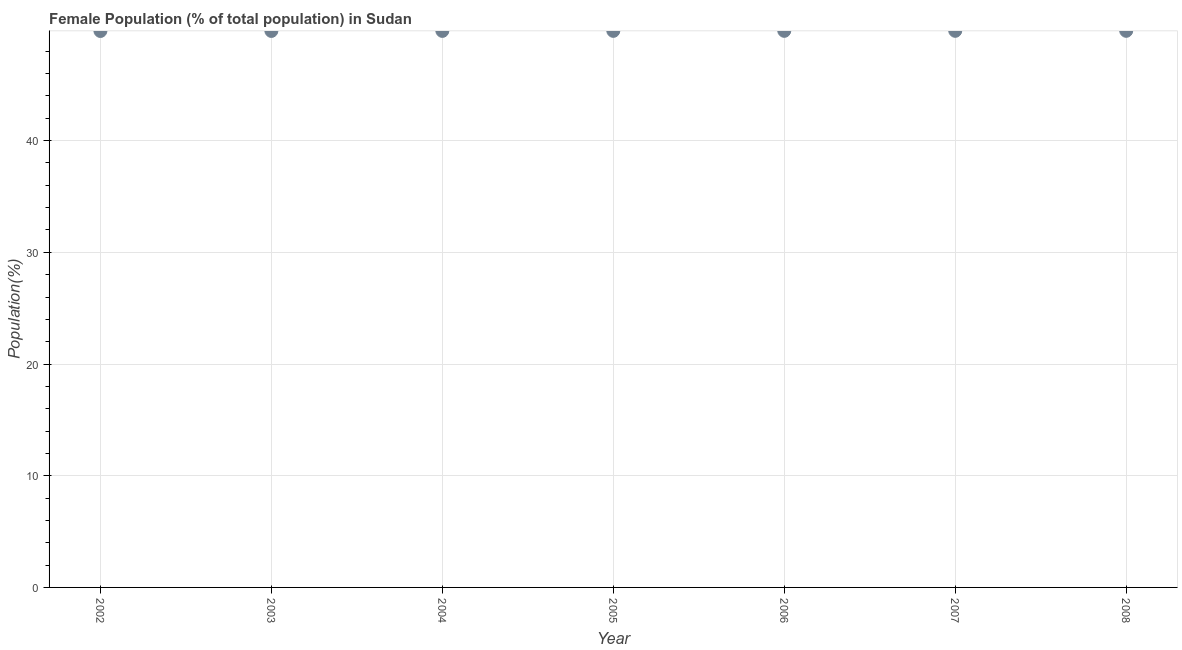What is the female population in 2004?
Ensure brevity in your answer.  49.82. Across all years, what is the maximum female population?
Keep it short and to the point. 49.83. Across all years, what is the minimum female population?
Provide a succinct answer. 49.82. In which year was the female population maximum?
Offer a terse response. 2008. What is the sum of the female population?
Ensure brevity in your answer.  348.78. What is the difference between the female population in 2007 and 2008?
Your response must be concise. -0. What is the average female population per year?
Your answer should be very brief. 49.83. What is the median female population?
Your answer should be very brief. 49.83. What is the ratio of the female population in 2005 to that in 2006?
Give a very brief answer. 1. Is the female population in 2004 less than that in 2008?
Offer a very short reply. Yes. What is the difference between the highest and the second highest female population?
Ensure brevity in your answer.  0. Is the sum of the female population in 2004 and 2005 greater than the maximum female population across all years?
Ensure brevity in your answer.  Yes. What is the difference between the highest and the lowest female population?
Make the answer very short. 0.01. In how many years, is the female population greater than the average female population taken over all years?
Give a very brief answer. 4. How many dotlines are there?
Your answer should be compact. 1. How many years are there in the graph?
Ensure brevity in your answer.  7. Does the graph contain grids?
Keep it short and to the point. Yes. What is the title of the graph?
Provide a short and direct response. Female Population (% of total population) in Sudan. What is the label or title of the Y-axis?
Provide a succinct answer. Population(%). What is the Population(%) in 2002?
Your answer should be very brief. 49.82. What is the Population(%) in 2003?
Keep it short and to the point. 49.82. What is the Population(%) in 2004?
Provide a succinct answer. 49.82. What is the Population(%) in 2005?
Your response must be concise. 49.83. What is the Population(%) in 2006?
Provide a succinct answer. 49.83. What is the Population(%) in 2007?
Offer a very short reply. 49.83. What is the Population(%) in 2008?
Your answer should be compact. 49.83. What is the difference between the Population(%) in 2002 and 2003?
Ensure brevity in your answer.  -0. What is the difference between the Population(%) in 2002 and 2004?
Keep it short and to the point. -0.01. What is the difference between the Population(%) in 2002 and 2005?
Give a very brief answer. -0.01. What is the difference between the Population(%) in 2002 and 2006?
Keep it short and to the point. -0.01. What is the difference between the Population(%) in 2002 and 2007?
Offer a terse response. -0.01. What is the difference between the Population(%) in 2002 and 2008?
Your answer should be compact. -0.01. What is the difference between the Population(%) in 2003 and 2004?
Your answer should be compact. -0. What is the difference between the Population(%) in 2003 and 2005?
Your answer should be compact. -0.01. What is the difference between the Population(%) in 2003 and 2006?
Give a very brief answer. -0.01. What is the difference between the Population(%) in 2003 and 2007?
Your answer should be compact. -0.01. What is the difference between the Population(%) in 2003 and 2008?
Ensure brevity in your answer.  -0.01. What is the difference between the Population(%) in 2004 and 2005?
Make the answer very short. -0. What is the difference between the Population(%) in 2004 and 2006?
Offer a terse response. -0. What is the difference between the Population(%) in 2004 and 2007?
Ensure brevity in your answer.  -0.01. What is the difference between the Population(%) in 2004 and 2008?
Give a very brief answer. -0.01. What is the difference between the Population(%) in 2005 and 2006?
Keep it short and to the point. -0. What is the difference between the Population(%) in 2005 and 2007?
Make the answer very short. -0. What is the difference between the Population(%) in 2005 and 2008?
Ensure brevity in your answer.  -0. What is the difference between the Population(%) in 2006 and 2007?
Your answer should be very brief. -0. What is the difference between the Population(%) in 2006 and 2008?
Your answer should be very brief. -0. What is the difference between the Population(%) in 2007 and 2008?
Your answer should be very brief. -0. What is the ratio of the Population(%) in 2002 to that in 2006?
Your answer should be very brief. 1. What is the ratio of the Population(%) in 2002 to that in 2007?
Provide a short and direct response. 1. What is the ratio of the Population(%) in 2002 to that in 2008?
Keep it short and to the point. 1. What is the ratio of the Population(%) in 2003 to that in 2004?
Keep it short and to the point. 1. What is the ratio of the Population(%) in 2003 to that in 2007?
Keep it short and to the point. 1. What is the ratio of the Population(%) in 2004 to that in 2005?
Offer a terse response. 1. What is the ratio of the Population(%) in 2004 to that in 2006?
Offer a terse response. 1. What is the ratio of the Population(%) in 2004 to that in 2007?
Your answer should be compact. 1. What is the ratio of the Population(%) in 2005 to that in 2007?
Your answer should be very brief. 1. What is the ratio of the Population(%) in 2005 to that in 2008?
Your answer should be very brief. 1. What is the ratio of the Population(%) in 2006 to that in 2008?
Keep it short and to the point. 1. 